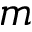Convert formula to latex. <formula><loc_0><loc_0><loc_500><loc_500>m</formula> 